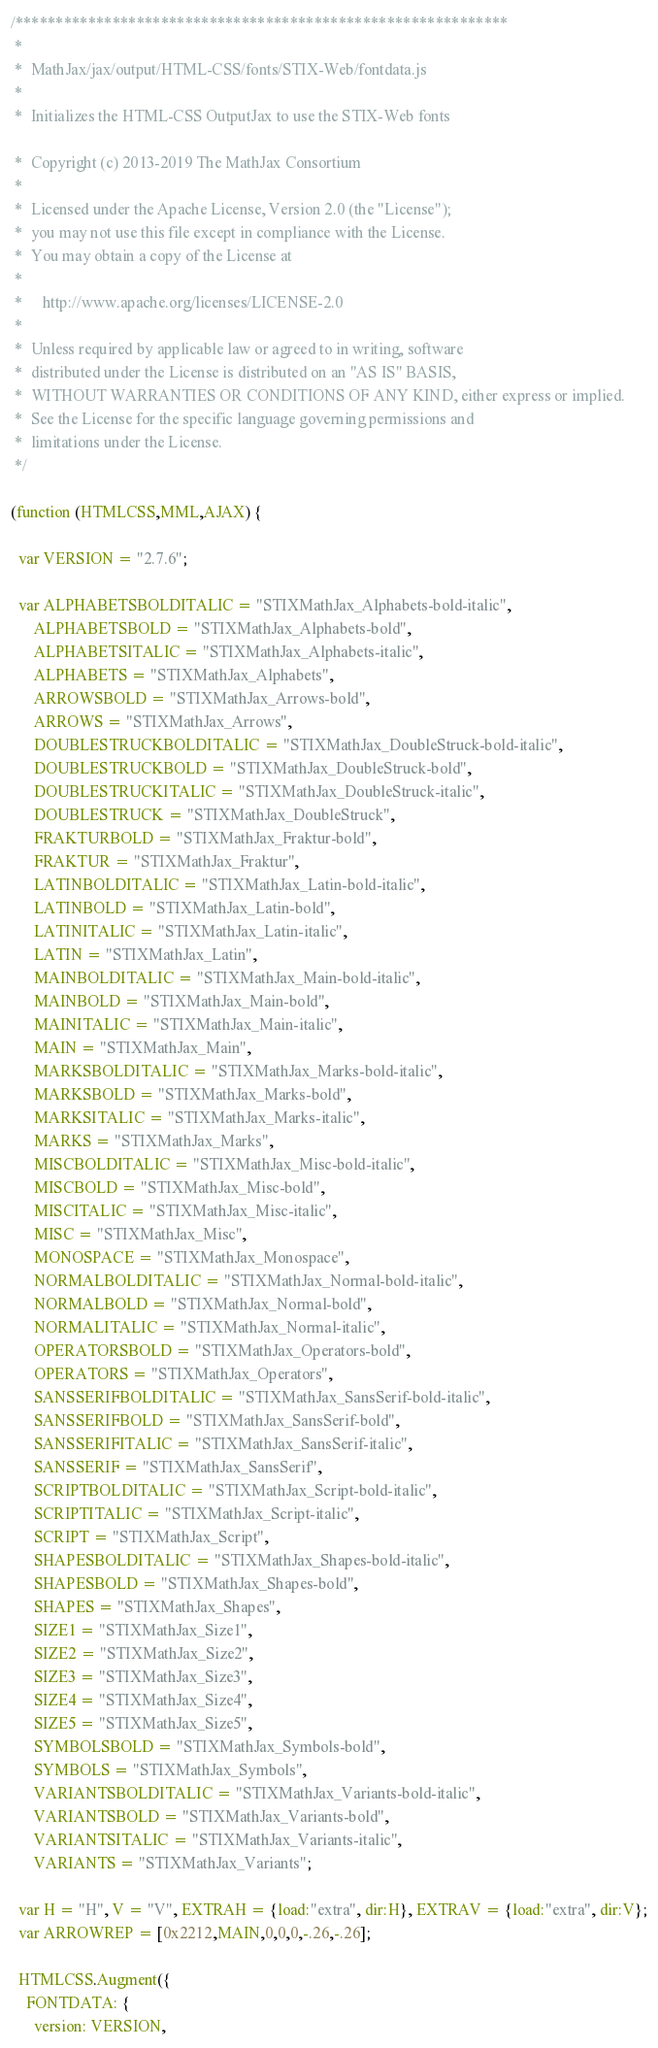Convert code to text. <code><loc_0><loc_0><loc_500><loc_500><_JavaScript_>/*************************************************************
 *
 *  MathJax/jax/output/HTML-CSS/fonts/STIX-Web/fontdata.js
 *  
 *  Initializes the HTML-CSS OutputJax to use the STIX-Web fonts

 *  Copyright (c) 2013-2019 The MathJax Consortium
 *
 *  Licensed under the Apache License, Version 2.0 (the "License");
 *  you may not use this file except in compliance with the License.
 *  You may obtain a copy of the License at
 *
 *     http://www.apache.org/licenses/LICENSE-2.0
 *
 *  Unless required by applicable law or agreed to in writing, software
 *  distributed under the License is distributed on an "AS IS" BASIS,
 *  WITHOUT WARRANTIES OR CONDITIONS OF ANY KIND, either express or implied.
 *  See the License for the specific language governing permissions and
 *  limitations under the License.
 */

(function (HTMLCSS,MML,AJAX) {

  var VERSION = "2.7.6";

  var ALPHABETSBOLDITALIC = "STIXMathJax_Alphabets-bold-italic",
      ALPHABETSBOLD = "STIXMathJax_Alphabets-bold",
      ALPHABETSITALIC = "STIXMathJax_Alphabets-italic",
      ALPHABETS = "STIXMathJax_Alphabets",
      ARROWSBOLD = "STIXMathJax_Arrows-bold",
      ARROWS = "STIXMathJax_Arrows",
      DOUBLESTRUCKBOLDITALIC = "STIXMathJax_DoubleStruck-bold-italic",
      DOUBLESTRUCKBOLD = "STIXMathJax_DoubleStruck-bold",
      DOUBLESTRUCKITALIC = "STIXMathJax_DoubleStruck-italic",
      DOUBLESTRUCK = "STIXMathJax_DoubleStruck",
      FRAKTURBOLD = "STIXMathJax_Fraktur-bold",
      FRAKTUR = "STIXMathJax_Fraktur",
      LATINBOLDITALIC = "STIXMathJax_Latin-bold-italic",
      LATINBOLD = "STIXMathJax_Latin-bold",
      LATINITALIC = "STIXMathJax_Latin-italic",
      LATIN = "STIXMathJax_Latin",
      MAINBOLDITALIC = "STIXMathJax_Main-bold-italic",
      MAINBOLD = "STIXMathJax_Main-bold",
      MAINITALIC = "STIXMathJax_Main-italic",
      MAIN = "STIXMathJax_Main",
      MARKSBOLDITALIC = "STIXMathJax_Marks-bold-italic",
      MARKSBOLD = "STIXMathJax_Marks-bold",
      MARKSITALIC = "STIXMathJax_Marks-italic",
      MARKS = "STIXMathJax_Marks",
      MISCBOLDITALIC = "STIXMathJax_Misc-bold-italic",
      MISCBOLD = "STIXMathJax_Misc-bold",
      MISCITALIC = "STIXMathJax_Misc-italic",
      MISC = "STIXMathJax_Misc",
      MONOSPACE = "STIXMathJax_Monospace",
      NORMALBOLDITALIC = "STIXMathJax_Normal-bold-italic",
      NORMALBOLD = "STIXMathJax_Normal-bold",
      NORMALITALIC = "STIXMathJax_Normal-italic",
      OPERATORSBOLD = "STIXMathJax_Operators-bold",
      OPERATORS = "STIXMathJax_Operators",
      SANSSERIFBOLDITALIC = "STIXMathJax_SansSerif-bold-italic",
      SANSSERIFBOLD = "STIXMathJax_SansSerif-bold",
      SANSSERIFITALIC = "STIXMathJax_SansSerif-italic",
      SANSSERIF = "STIXMathJax_SansSerif",
      SCRIPTBOLDITALIC = "STIXMathJax_Script-bold-italic",
      SCRIPTITALIC = "STIXMathJax_Script-italic",
      SCRIPT = "STIXMathJax_Script",
      SHAPESBOLDITALIC = "STIXMathJax_Shapes-bold-italic",
      SHAPESBOLD = "STIXMathJax_Shapes-bold",
      SHAPES = "STIXMathJax_Shapes",
      SIZE1 = "STIXMathJax_Size1",
      SIZE2 = "STIXMathJax_Size2",
      SIZE3 = "STIXMathJax_Size3",
      SIZE4 = "STIXMathJax_Size4",
      SIZE5 = "STIXMathJax_Size5",
      SYMBOLSBOLD = "STIXMathJax_Symbols-bold",
      SYMBOLS = "STIXMathJax_Symbols",
      VARIANTSBOLDITALIC = "STIXMathJax_Variants-bold-italic",
      VARIANTSBOLD = "STIXMathJax_Variants-bold",
      VARIANTSITALIC = "STIXMathJax_Variants-italic",
      VARIANTS = "STIXMathJax_Variants";

  var H = "H", V = "V", EXTRAH = {load:"extra", dir:H}, EXTRAV = {load:"extra", dir:V};
  var ARROWREP = [0x2212,MAIN,0,0,0,-.26,-.26];

  HTMLCSS.Augment({
    FONTDATA: {
      version: VERSION,

</code> 